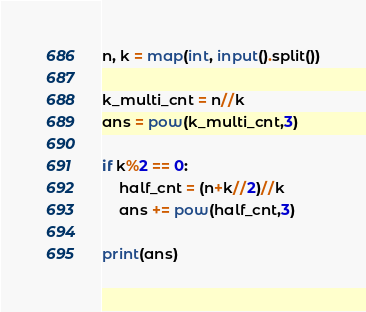<code> <loc_0><loc_0><loc_500><loc_500><_Python_>n, k = map(int, input().split())

k_multi_cnt = n//k
ans = pow(k_multi_cnt,3)

if k%2 == 0:
    half_cnt = (n+k//2)//k
    ans += pow(half_cnt,3)

print(ans)</code> 